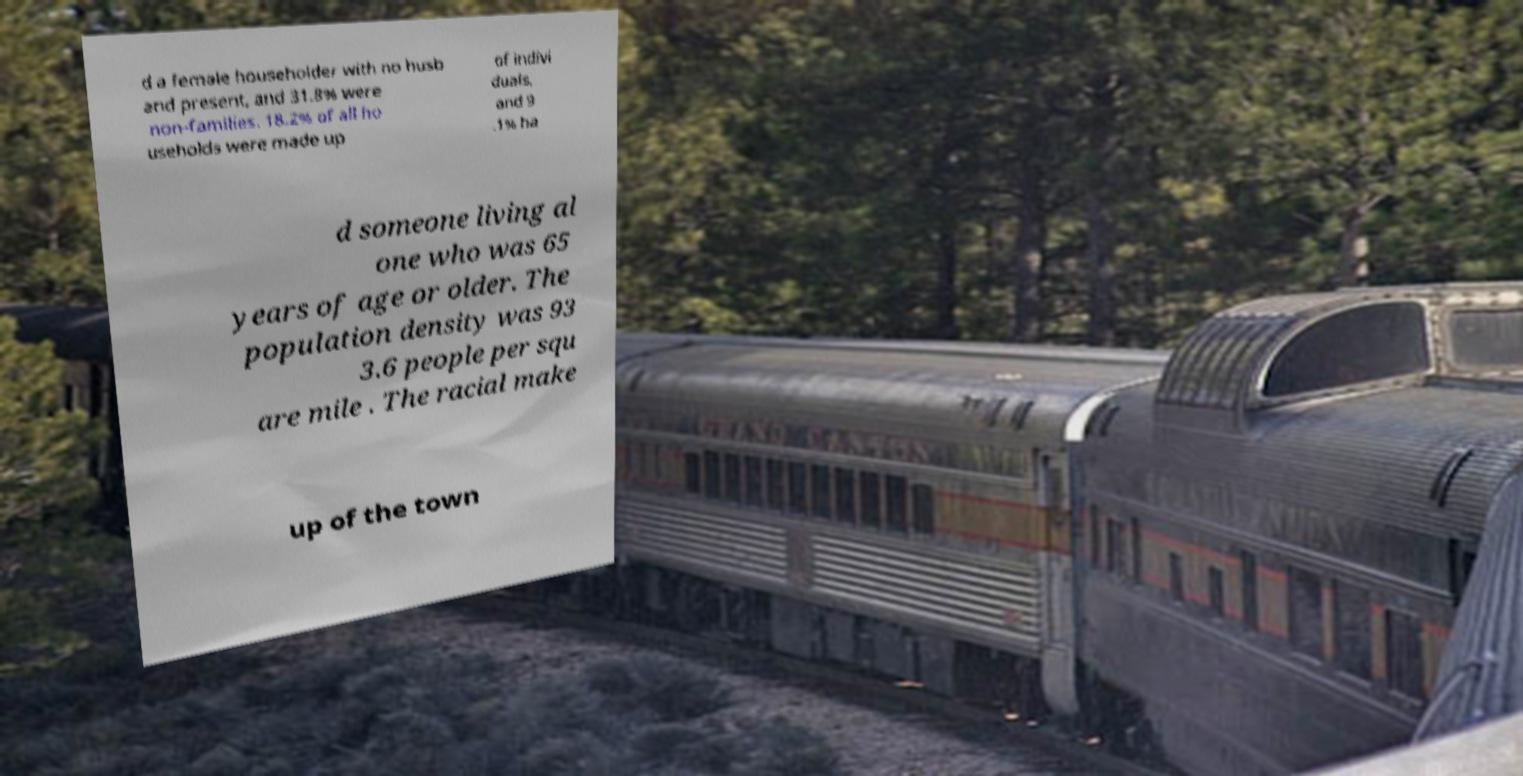Can you read and provide the text displayed in the image?This photo seems to have some interesting text. Can you extract and type it out for me? d a female householder with no husb and present, and 31.8% were non-families. 18.2% of all ho useholds were made up of indivi duals, and 9 .1% ha d someone living al one who was 65 years of age or older. The population density was 93 3.6 people per squ are mile . The racial make up of the town 